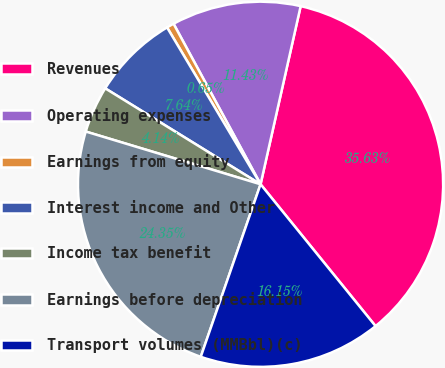Convert chart to OTSL. <chart><loc_0><loc_0><loc_500><loc_500><pie_chart><fcel>Revenues<fcel>Operating expenses<fcel>Earnings from equity<fcel>Interest income and Other<fcel>Income tax benefit<fcel>Earnings before depreciation<fcel>Transport volumes (MMBbl)(c)<nl><fcel>35.63%<fcel>11.43%<fcel>0.65%<fcel>7.64%<fcel>4.14%<fcel>24.35%<fcel>16.15%<nl></chart> 